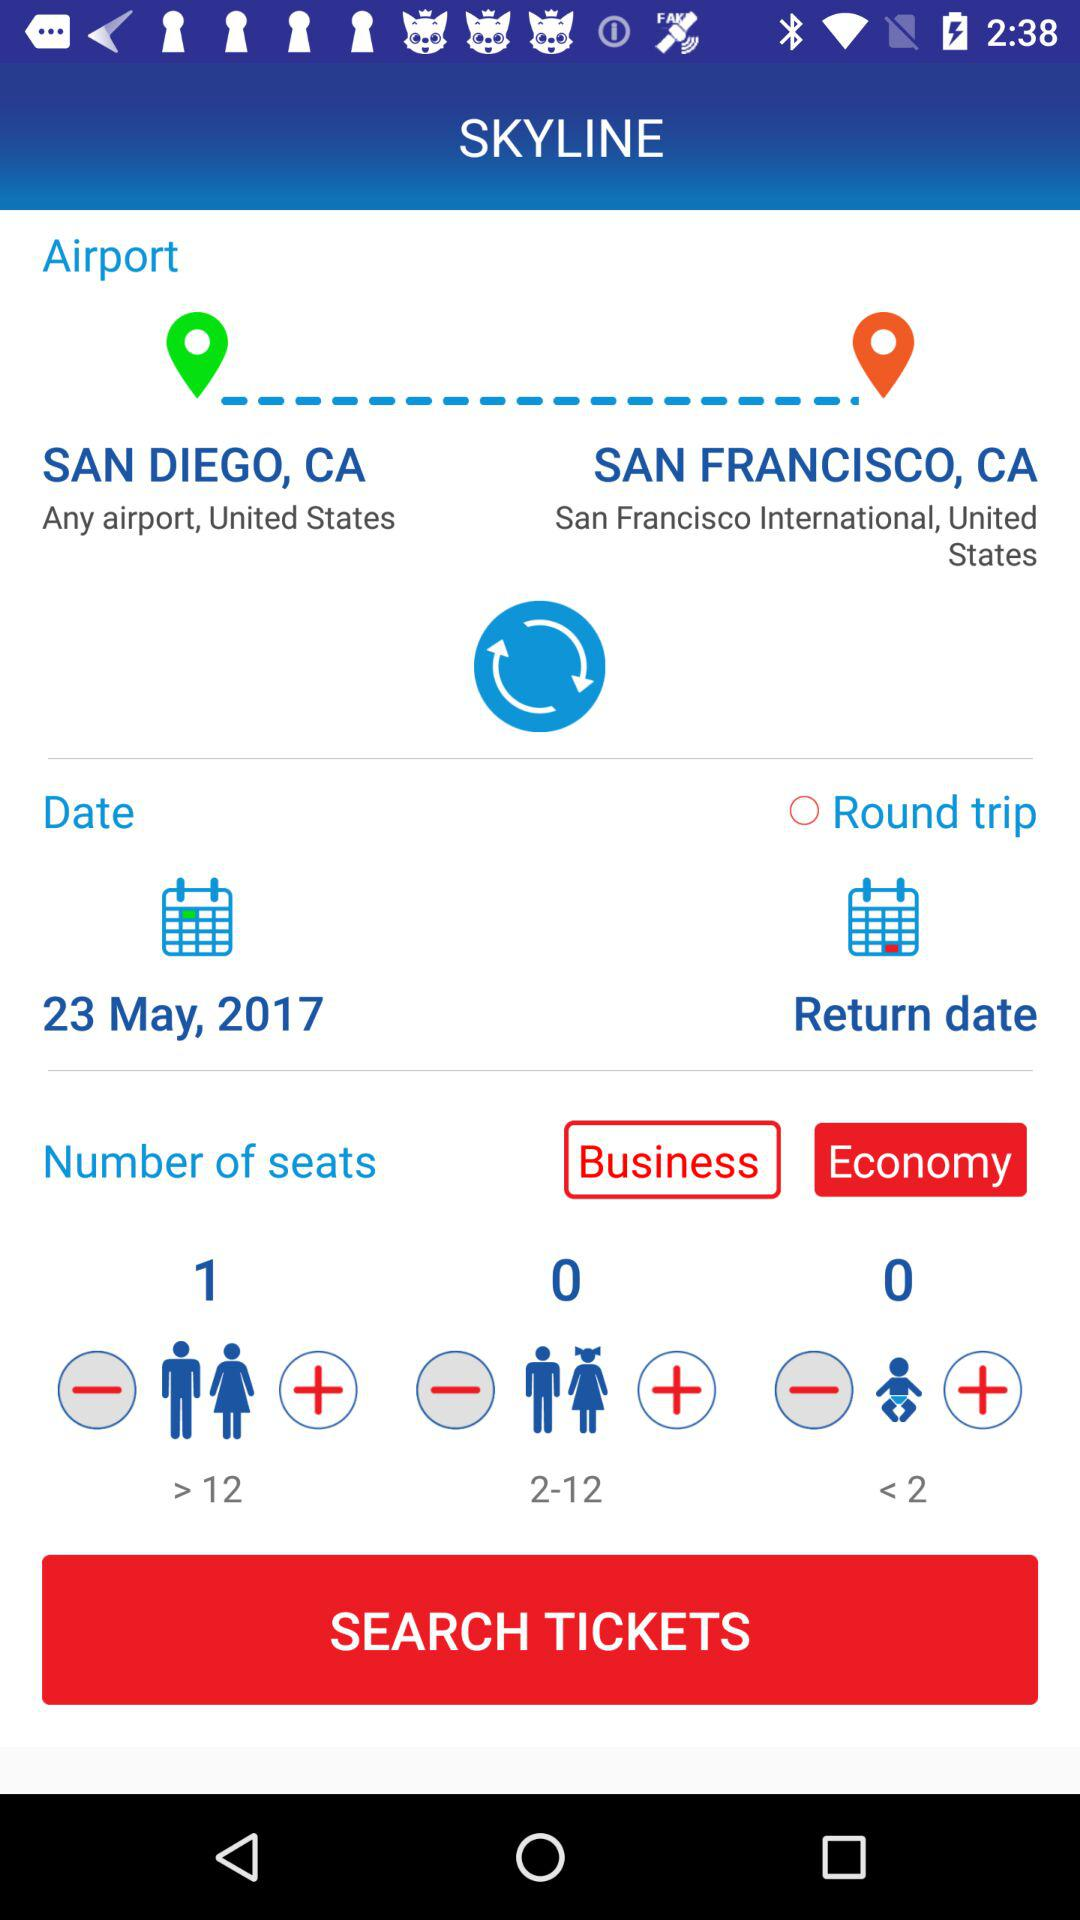Which option is selected out of "Business" and "Economy"? The selected option is "Economy". 